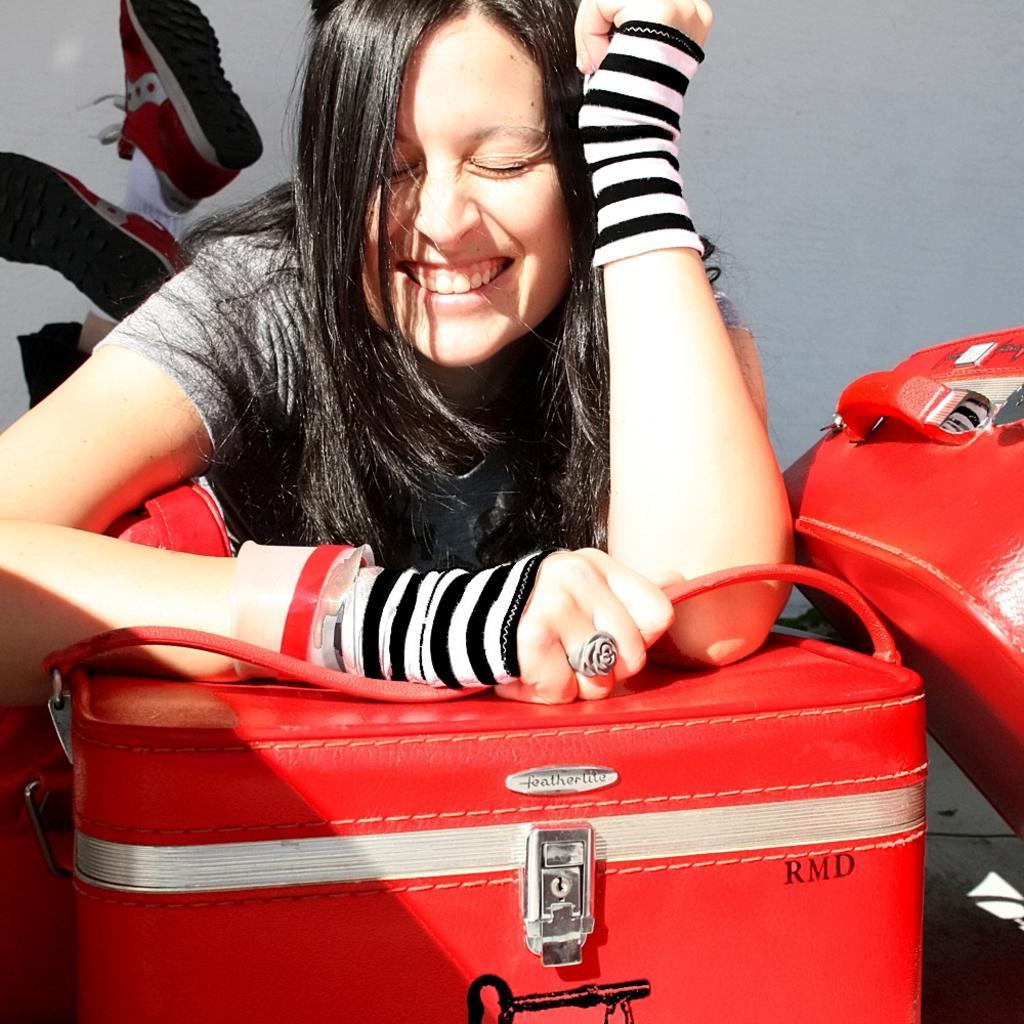Please provide a concise description of this image. In the image we can see there is a woman who is smiling and she is holding a red colour suitcase handle. 